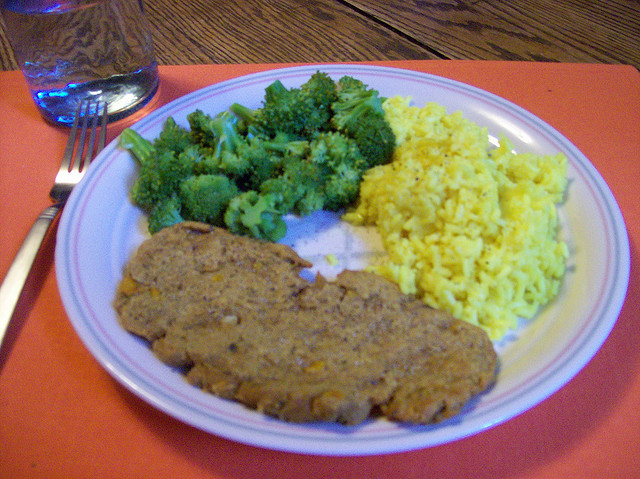<image>What kind of rice is in the bowl? I am not aware what kind of rice is in the bowl as it could be yellow, white, steam, cheesy or chicken flavored. What kind of rice is in the bowl? I am not sure what kind of rice is in the bowl. It can be chicken flavored, cheesy, white, yellow or none. 